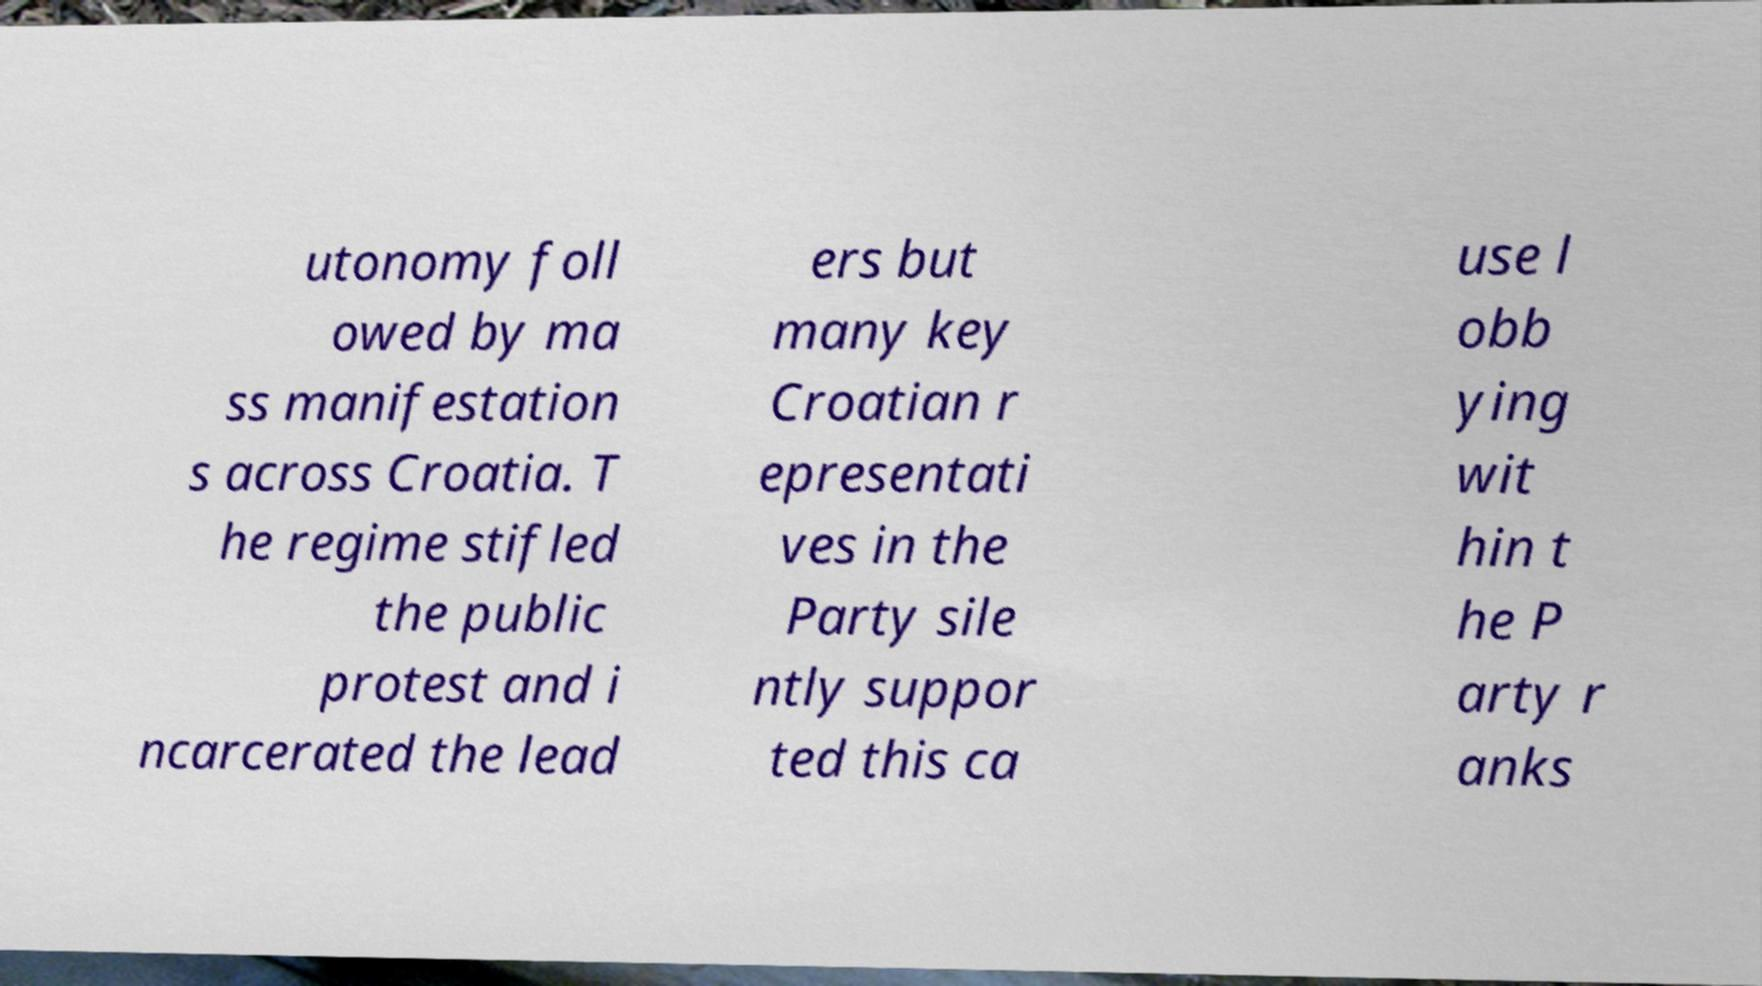Can you read and provide the text displayed in the image?This photo seems to have some interesting text. Can you extract and type it out for me? utonomy foll owed by ma ss manifestation s across Croatia. T he regime stifled the public protest and i ncarcerated the lead ers but many key Croatian r epresentati ves in the Party sile ntly suppor ted this ca use l obb ying wit hin t he P arty r anks 